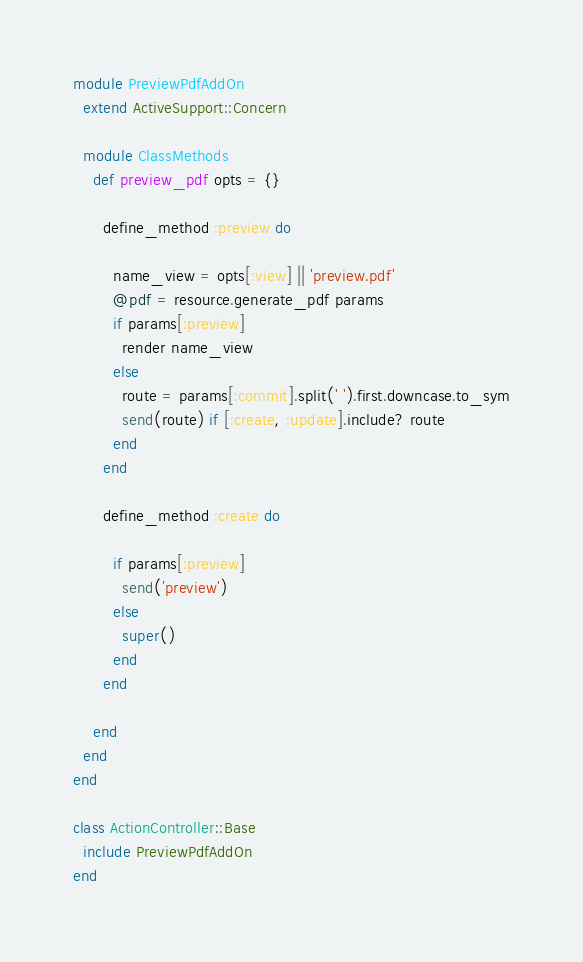<code> <loc_0><loc_0><loc_500><loc_500><_Ruby_>module PreviewPdfAddOn
  extend ActiveSupport::Concern

  module ClassMethods
    def preview_pdf opts = {}

      define_method :preview do
      
        name_view = opts[:view] || 'preview.pdf'
        @pdf = resource.generate_pdf params
        if params[:preview]
          render name_view
        else
          route = params[:commit].split(' ').first.downcase.to_sym
          send(route) if [:create, :update].include? route
        end
      end

      define_method :create do
      
        if params[:preview]
          send('preview')
        else
          super()
        end
      end

    end
  end
end

class ActionController::Base
  include PreviewPdfAddOn
end
</code> 